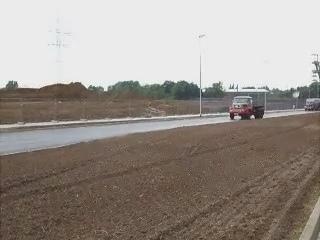How many vehicles are there?
Give a very brief answer. 2. How many boats are parked?
Give a very brief answer. 0. 